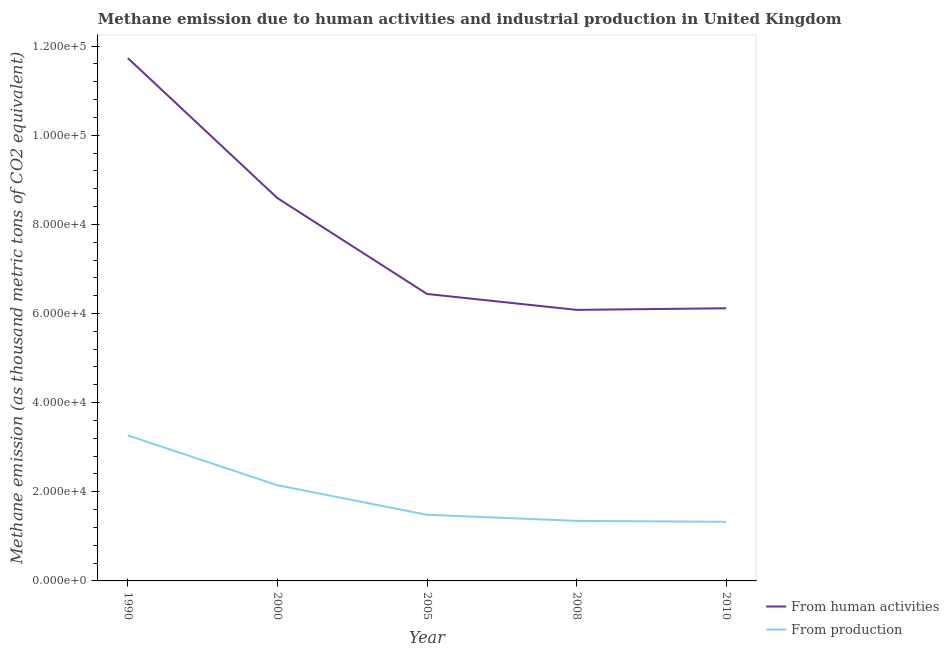Does the line corresponding to amount of emissions generated from industries intersect with the line corresponding to amount of emissions from human activities?
Provide a short and direct response. No. Is the number of lines equal to the number of legend labels?
Your response must be concise. Yes. What is the amount of emissions generated from industries in 2005?
Provide a succinct answer. 1.48e+04. Across all years, what is the maximum amount of emissions from human activities?
Offer a terse response. 1.17e+05. Across all years, what is the minimum amount of emissions generated from industries?
Make the answer very short. 1.33e+04. In which year was the amount of emissions from human activities maximum?
Ensure brevity in your answer.  1990. What is the total amount of emissions generated from industries in the graph?
Offer a very short reply. 9.57e+04. What is the difference between the amount of emissions generated from industries in 2000 and that in 2008?
Your answer should be compact. 8001.7. What is the difference between the amount of emissions generated from industries in 2008 and the amount of emissions from human activities in 1990?
Your response must be concise. -1.04e+05. What is the average amount of emissions generated from industries per year?
Provide a succinct answer. 1.91e+04. In the year 2008, what is the difference between the amount of emissions from human activities and amount of emissions generated from industries?
Give a very brief answer. 4.73e+04. What is the ratio of the amount of emissions from human activities in 2005 to that in 2010?
Make the answer very short. 1.05. Is the amount of emissions generated from industries in 2000 less than that in 2010?
Give a very brief answer. No. What is the difference between the highest and the second highest amount of emissions generated from industries?
Ensure brevity in your answer.  1.12e+04. What is the difference between the highest and the lowest amount of emissions from human activities?
Offer a very short reply. 5.65e+04. Does the amount of emissions from human activities monotonically increase over the years?
Offer a terse response. No. Is the amount of emissions from human activities strictly greater than the amount of emissions generated from industries over the years?
Provide a succinct answer. Yes. How many lines are there?
Make the answer very short. 2. What is the difference between two consecutive major ticks on the Y-axis?
Offer a terse response. 2.00e+04. Are the values on the major ticks of Y-axis written in scientific E-notation?
Ensure brevity in your answer.  Yes. Does the graph contain any zero values?
Your answer should be very brief. No. How are the legend labels stacked?
Provide a short and direct response. Vertical. What is the title of the graph?
Your response must be concise. Methane emission due to human activities and industrial production in United Kingdom. Does "UN agencies" appear as one of the legend labels in the graph?
Keep it short and to the point. No. What is the label or title of the X-axis?
Ensure brevity in your answer.  Year. What is the label or title of the Y-axis?
Your answer should be compact. Methane emission (as thousand metric tons of CO2 equivalent). What is the Methane emission (as thousand metric tons of CO2 equivalent) in From human activities in 1990?
Make the answer very short. 1.17e+05. What is the Methane emission (as thousand metric tons of CO2 equivalent) in From production in 1990?
Offer a terse response. 3.27e+04. What is the Methane emission (as thousand metric tons of CO2 equivalent) of From human activities in 2000?
Your answer should be compact. 8.59e+04. What is the Methane emission (as thousand metric tons of CO2 equivalent) in From production in 2000?
Your answer should be very brief. 2.15e+04. What is the Methane emission (as thousand metric tons of CO2 equivalent) in From human activities in 2005?
Give a very brief answer. 6.44e+04. What is the Methane emission (as thousand metric tons of CO2 equivalent) of From production in 2005?
Provide a short and direct response. 1.48e+04. What is the Methane emission (as thousand metric tons of CO2 equivalent) in From human activities in 2008?
Your response must be concise. 6.08e+04. What is the Methane emission (as thousand metric tons of CO2 equivalent) in From production in 2008?
Offer a terse response. 1.35e+04. What is the Methane emission (as thousand metric tons of CO2 equivalent) in From human activities in 2010?
Provide a succinct answer. 6.12e+04. What is the Methane emission (as thousand metric tons of CO2 equivalent) in From production in 2010?
Ensure brevity in your answer.  1.33e+04. Across all years, what is the maximum Methane emission (as thousand metric tons of CO2 equivalent) of From human activities?
Give a very brief answer. 1.17e+05. Across all years, what is the maximum Methane emission (as thousand metric tons of CO2 equivalent) in From production?
Offer a very short reply. 3.27e+04. Across all years, what is the minimum Methane emission (as thousand metric tons of CO2 equivalent) in From human activities?
Your answer should be compact. 6.08e+04. Across all years, what is the minimum Methane emission (as thousand metric tons of CO2 equivalent) of From production?
Offer a terse response. 1.33e+04. What is the total Methane emission (as thousand metric tons of CO2 equivalent) of From human activities in the graph?
Your answer should be very brief. 3.90e+05. What is the total Methane emission (as thousand metric tons of CO2 equivalent) of From production in the graph?
Offer a very short reply. 9.57e+04. What is the difference between the Methane emission (as thousand metric tons of CO2 equivalent) of From human activities in 1990 and that in 2000?
Your response must be concise. 3.14e+04. What is the difference between the Methane emission (as thousand metric tons of CO2 equivalent) in From production in 1990 and that in 2000?
Keep it short and to the point. 1.12e+04. What is the difference between the Methane emission (as thousand metric tons of CO2 equivalent) of From human activities in 1990 and that in 2005?
Your answer should be compact. 5.29e+04. What is the difference between the Methane emission (as thousand metric tons of CO2 equivalent) of From production in 1990 and that in 2005?
Make the answer very short. 1.78e+04. What is the difference between the Methane emission (as thousand metric tons of CO2 equivalent) of From human activities in 1990 and that in 2008?
Ensure brevity in your answer.  5.65e+04. What is the difference between the Methane emission (as thousand metric tons of CO2 equivalent) in From production in 1990 and that in 2008?
Make the answer very short. 1.92e+04. What is the difference between the Methane emission (as thousand metric tons of CO2 equivalent) in From human activities in 1990 and that in 2010?
Your answer should be compact. 5.61e+04. What is the difference between the Methane emission (as thousand metric tons of CO2 equivalent) in From production in 1990 and that in 2010?
Give a very brief answer. 1.94e+04. What is the difference between the Methane emission (as thousand metric tons of CO2 equivalent) in From human activities in 2000 and that in 2005?
Keep it short and to the point. 2.15e+04. What is the difference between the Methane emission (as thousand metric tons of CO2 equivalent) in From production in 2000 and that in 2005?
Give a very brief answer. 6631. What is the difference between the Methane emission (as thousand metric tons of CO2 equivalent) of From human activities in 2000 and that in 2008?
Your answer should be very brief. 2.51e+04. What is the difference between the Methane emission (as thousand metric tons of CO2 equivalent) of From production in 2000 and that in 2008?
Keep it short and to the point. 8001.7. What is the difference between the Methane emission (as thousand metric tons of CO2 equivalent) of From human activities in 2000 and that in 2010?
Give a very brief answer. 2.47e+04. What is the difference between the Methane emission (as thousand metric tons of CO2 equivalent) in From production in 2000 and that in 2010?
Offer a terse response. 8210. What is the difference between the Methane emission (as thousand metric tons of CO2 equivalent) in From human activities in 2005 and that in 2008?
Offer a terse response. 3573.1. What is the difference between the Methane emission (as thousand metric tons of CO2 equivalent) of From production in 2005 and that in 2008?
Provide a short and direct response. 1370.7. What is the difference between the Methane emission (as thousand metric tons of CO2 equivalent) of From human activities in 2005 and that in 2010?
Provide a succinct answer. 3212.9. What is the difference between the Methane emission (as thousand metric tons of CO2 equivalent) in From production in 2005 and that in 2010?
Offer a very short reply. 1579. What is the difference between the Methane emission (as thousand metric tons of CO2 equivalent) of From human activities in 2008 and that in 2010?
Provide a succinct answer. -360.2. What is the difference between the Methane emission (as thousand metric tons of CO2 equivalent) of From production in 2008 and that in 2010?
Your answer should be very brief. 208.3. What is the difference between the Methane emission (as thousand metric tons of CO2 equivalent) of From human activities in 1990 and the Methane emission (as thousand metric tons of CO2 equivalent) of From production in 2000?
Provide a short and direct response. 9.58e+04. What is the difference between the Methane emission (as thousand metric tons of CO2 equivalent) of From human activities in 1990 and the Methane emission (as thousand metric tons of CO2 equivalent) of From production in 2005?
Keep it short and to the point. 1.02e+05. What is the difference between the Methane emission (as thousand metric tons of CO2 equivalent) in From human activities in 1990 and the Methane emission (as thousand metric tons of CO2 equivalent) in From production in 2008?
Provide a succinct answer. 1.04e+05. What is the difference between the Methane emission (as thousand metric tons of CO2 equivalent) in From human activities in 1990 and the Methane emission (as thousand metric tons of CO2 equivalent) in From production in 2010?
Provide a succinct answer. 1.04e+05. What is the difference between the Methane emission (as thousand metric tons of CO2 equivalent) in From human activities in 2000 and the Methane emission (as thousand metric tons of CO2 equivalent) in From production in 2005?
Provide a succinct answer. 7.11e+04. What is the difference between the Methane emission (as thousand metric tons of CO2 equivalent) in From human activities in 2000 and the Methane emission (as thousand metric tons of CO2 equivalent) in From production in 2008?
Provide a short and direct response. 7.24e+04. What is the difference between the Methane emission (as thousand metric tons of CO2 equivalent) in From human activities in 2000 and the Methane emission (as thousand metric tons of CO2 equivalent) in From production in 2010?
Your response must be concise. 7.26e+04. What is the difference between the Methane emission (as thousand metric tons of CO2 equivalent) in From human activities in 2005 and the Methane emission (as thousand metric tons of CO2 equivalent) in From production in 2008?
Keep it short and to the point. 5.09e+04. What is the difference between the Methane emission (as thousand metric tons of CO2 equivalent) in From human activities in 2005 and the Methane emission (as thousand metric tons of CO2 equivalent) in From production in 2010?
Give a very brief answer. 5.11e+04. What is the difference between the Methane emission (as thousand metric tons of CO2 equivalent) of From human activities in 2008 and the Methane emission (as thousand metric tons of CO2 equivalent) of From production in 2010?
Provide a short and direct response. 4.76e+04. What is the average Methane emission (as thousand metric tons of CO2 equivalent) in From human activities per year?
Your answer should be compact. 7.79e+04. What is the average Methane emission (as thousand metric tons of CO2 equivalent) of From production per year?
Provide a succinct answer. 1.91e+04. In the year 1990, what is the difference between the Methane emission (as thousand metric tons of CO2 equivalent) of From human activities and Methane emission (as thousand metric tons of CO2 equivalent) of From production?
Your answer should be compact. 8.47e+04. In the year 2000, what is the difference between the Methane emission (as thousand metric tons of CO2 equivalent) of From human activities and Methane emission (as thousand metric tons of CO2 equivalent) of From production?
Keep it short and to the point. 6.44e+04. In the year 2005, what is the difference between the Methane emission (as thousand metric tons of CO2 equivalent) of From human activities and Methane emission (as thousand metric tons of CO2 equivalent) of From production?
Offer a terse response. 4.95e+04. In the year 2008, what is the difference between the Methane emission (as thousand metric tons of CO2 equivalent) in From human activities and Methane emission (as thousand metric tons of CO2 equivalent) in From production?
Provide a succinct answer. 4.73e+04. In the year 2010, what is the difference between the Methane emission (as thousand metric tons of CO2 equivalent) of From human activities and Methane emission (as thousand metric tons of CO2 equivalent) of From production?
Give a very brief answer. 4.79e+04. What is the ratio of the Methane emission (as thousand metric tons of CO2 equivalent) in From human activities in 1990 to that in 2000?
Provide a succinct answer. 1.37. What is the ratio of the Methane emission (as thousand metric tons of CO2 equivalent) in From production in 1990 to that in 2000?
Give a very brief answer. 1.52. What is the ratio of the Methane emission (as thousand metric tons of CO2 equivalent) of From human activities in 1990 to that in 2005?
Provide a short and direct response. 1.82. What is the ratio of the Methane emission (as thousand metric tons of CO2 equivalent) of From production in 1990 to that in 2005?
Your answer should be very brief. 2.2. What is the ratio of the Methane emission (as thousand metric tons of CO2 equivalent) of From human activities in 1990 to that in 2008?
Provide a short and direct response. 1.93. What is the ratio of the Methane emission (as thousand metric tons of CO2 equivalent) of From production in 1990 to that in 2008?
Ensure brevity in your answer.  2.42. What is the ratio of the Methane emission (as thousand metric tons of CO2 equivalent) in From human activities in 1990 to that in 2010?
Offer a very short reply. 1.92. What is the ratio of the Methane emission (as thousand metric tons of CO2 equivalent) in From production in 1990 to that in 2010?
Your answer should be very brief. 2.46. What is the ratio of the Methane emission (as thousand metric tons of CO2 equivalent) of From human activities in 2000 to that in 2005?
Your response must be concise. 1.33. What is the ratio of the Methane emission (as thousand metric tons of CO2 equivalent) in From production in 2000 to that in 2005?
Your answer should be compact. 1.45. What is the ratio of the Methane emission (as thousand metric tons of CO2 equivalent) of From human activities in 2000 to that in 2008?
Give a very brief answer. 1.41. What is the ratio of the Methane emission (as thousand metric tons of CO2 equivalent) in From production in 2000 to that in 2008?
Your answer should be compact. 1.59. What is the ratio of the Methane emission (as thousand metric tons of CO2 equivalent) of From human activities in 2000 to that in 2010?
Provide a succinct answer. 1.4. What is the ratio of the Methane emission (as thousand metric tons of CO2 equivalent) in From production in 2000 to that in 2010?
Offer a very short reply. 1.62. What is the ratio of the Methane emission (as thousand metric tons of CO2 equivalent) in From human activities in 2005 to that in 2008?
Your answer should be compact. 1.06. What is the ratio of the Methane emission (as thousand metric tons of CO2 equivalent) of From production in 2005 to that in 2008?
Ensure brevity in your answer.  1.1. What is the ratio of the Methane emission (as thousand metric tons of CO2 equivalent) of From human activities in 2005 to that in 2010?
Give a very brief answer. 1.05. What is the ratio of the Methane emission (as thousand metric tons of CO2 equivalent) of From production in 2005 to that in 2010?
Ensure brevity in your answer.  1.12. What is the ratio of the Methane emission (as thousand metric tons of CO2 equivalent) of From human activities in 2008 to that in 2010?
Your response must be concise. 0.99. What is the ratio of the Methane emission (as thousand metric tons of CO2 equivalent) in From production in 2008 to that in 2010?
Keep it short and to the point. 1.02. What is the difference between the highest and the second highest Methane emission (as thousand metric tons of CO2 equivalent) of From human activities?
Your answer should be compact. 3.14e+04. What is the difference between the highest and the second highest Methane emission (as thousand metric tons of CO2 equivalent) of From production?
Offer a very short reply. 1.12e+04. What is the difference between the highest and the lowest Methane emission (as thousand metric tons of CO2 equivalent) of From human activities?
Keep it short and to the point. 5.65e+04. What is the difference between the highest and the lowest Methane emission (as thousand metric tons of CO2 equivalent) of From production?
Give a very brief answer. 1.94e+04. 